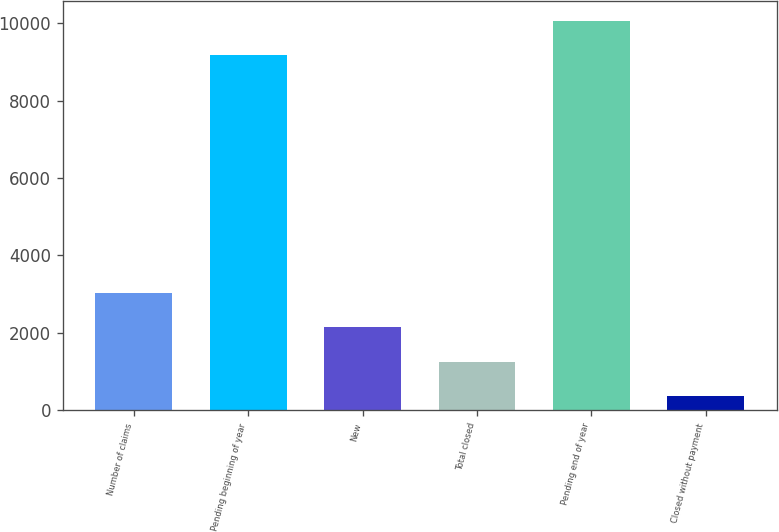<chart> <loc_0><loc_0><loc_500><loc_500><bar_chart><fcel>Number of claims<fcel>Pending beginning of year<fcel>New<fcel>Total closed<fcel>Pending end of year<fcel>Closed without payment<nl><fcel>3031.6<fcel>9175<fcel>2142.4<fcel>1253.2<fcel>10064.2<fcel>364<nl></chart> 